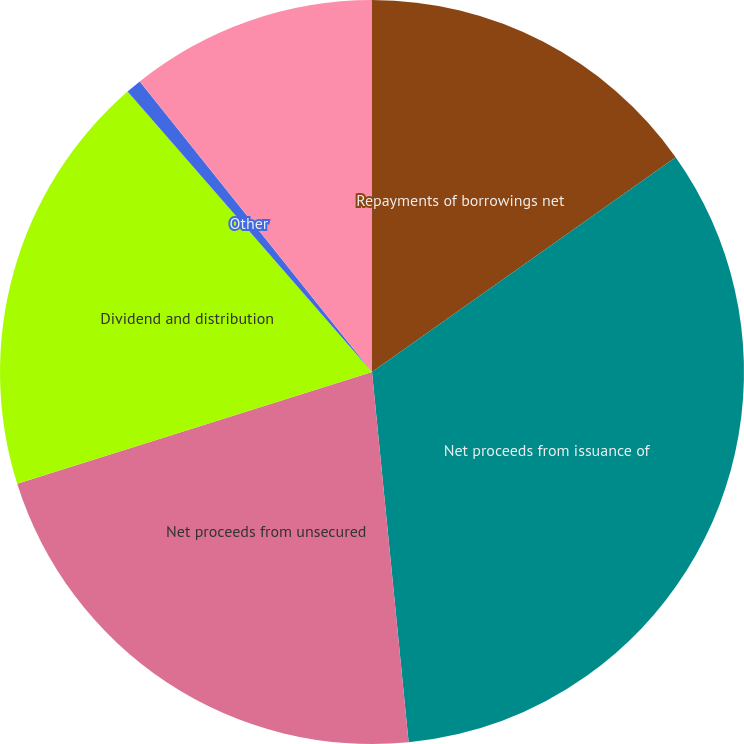Convert chart to OTSL. <chart><loc_0><loc_0><loc_500><loc_500><pie_chart><fcel>Repayments of borrowings net<fcel>Net proceeds from issuance of<fcel>Net proceeds from unsecured<fcel>Dividend and distribution<fcel>Other<fcel>Net cash provided by (used in)<nl><fcel>15.2%<fcel>33.23%<fcel>21.71%<fcel>18.45%<fcel>0.68%<fcel>10.73%<nl></chart> 